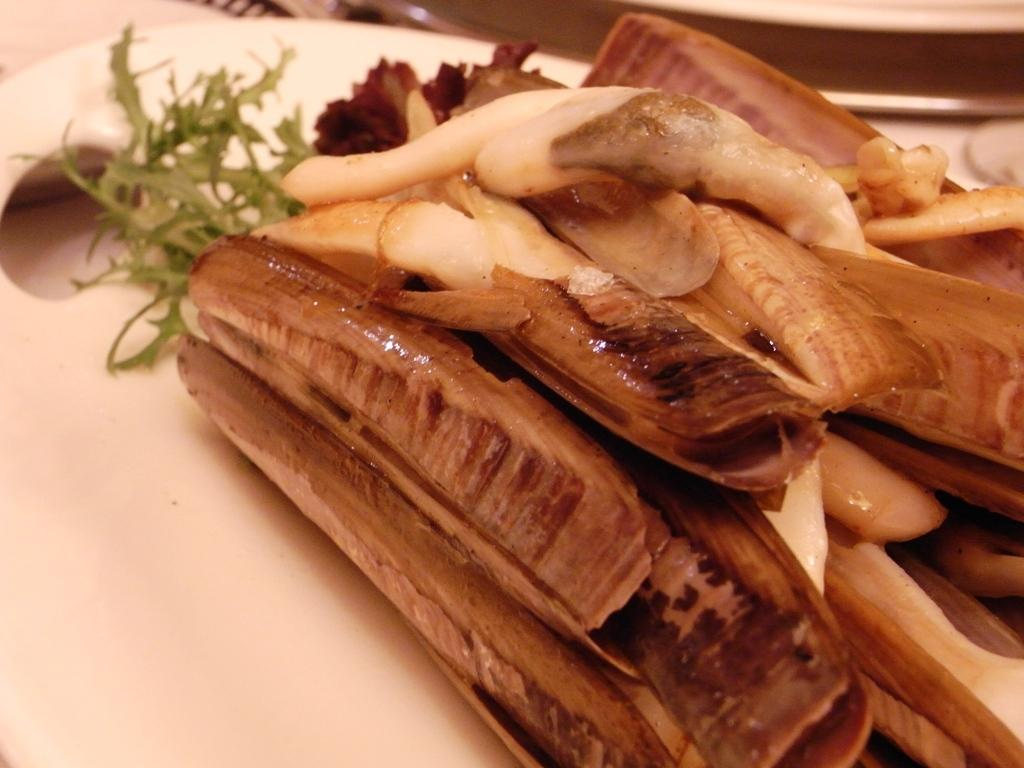What type of vegetables are present in the image? There are radishes in the image. What is the color of the radishes? The radishes are brown in color. Where are the radishes placed in the image? The radishes are kept on a chopping board. What can be inferred about the setting of the image? The image appears to be taken in a kitchen. Can you see a boat in the image? No, there is no boat present in the image. What type of observation can be made about the radishes in the image? The provided facts do not mention any specific observations about the radishes, so it is not possible to answer this question. 